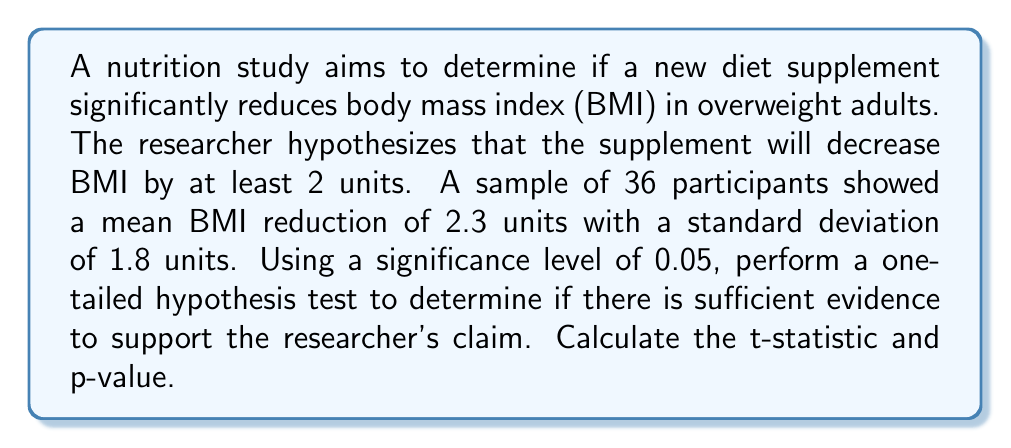Give your solution to this math problem. 1. Define the hypotheses:
   $H_0: \mu \leq 2$ (null hypothesis)
   $H_a: \mu > 2$ (alternative hypothesis)

2. Given information:
   - Sample size: $n = 36$
   - Sample mean: $\bar{x} = 2.3$
   - Sample standard deviation: $s = 1.8$
   - Significance level: $\alpha = 0.05$
   - Hypothesized mean: $\mu_0 = 2$

3. Calculate the t-statistic:
   $$t = \frac{\bar{x} - \mu_0}{s/\sqrt{n}} = \frac{2.3 - 2}{1.8/\sqrt{36}} = \frac{0.3}{0.3} = 1$$

4. Determine the degrees of freedom:
   $df = n - 1 = 36 - 1 = 35$

5. Find the critical t-value for a one-tailed test with $\alpha = 0.05$ and $df = 35$:
   $t_{critical} = 1.6896$ (from t-distribution table)

6. Compare the calculated t-statistic to the critical t-value:
   Since $1 < 1.6896$, we fail to reject the null hypothesis.

7. Calculate the p-value:
   Using a t-distribution calculator or table, we find:
   $p-value = P(T > 1) = 0.1619$ for $df = 35$

8. Compare the p-value to the significance level:
   Since $0.1619 > 0.05$, we fail to reject the null hypothesis.

Conclusion: There is not sufficient evidence to support the researcher's claim that the supplement decreases BMI by at least 2 units at a 0.05 significance level.
Answer: $t = 1$, $p-value = 0.1619$ 